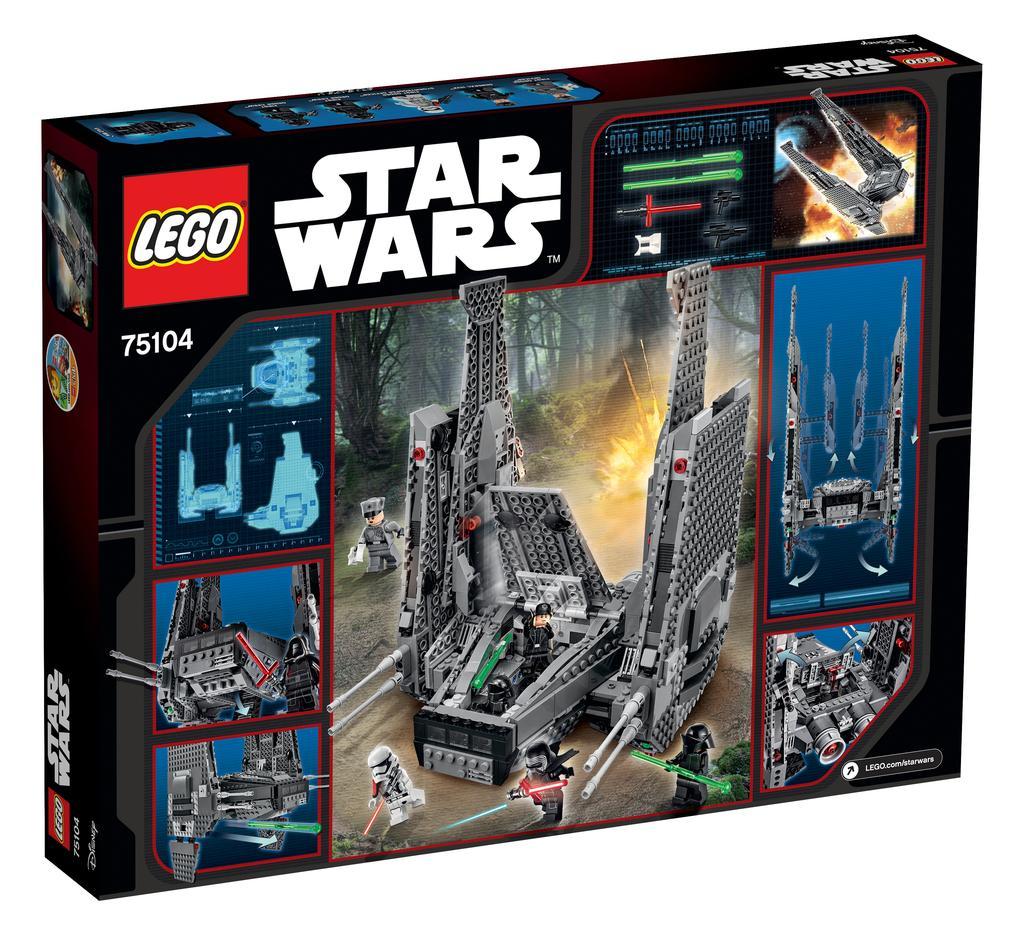How would you summarize this image in a sentence or two? In the picture I can see a box which has pictures of toys and some other things. I can also see something written on the box. The background of the image is white in color. 